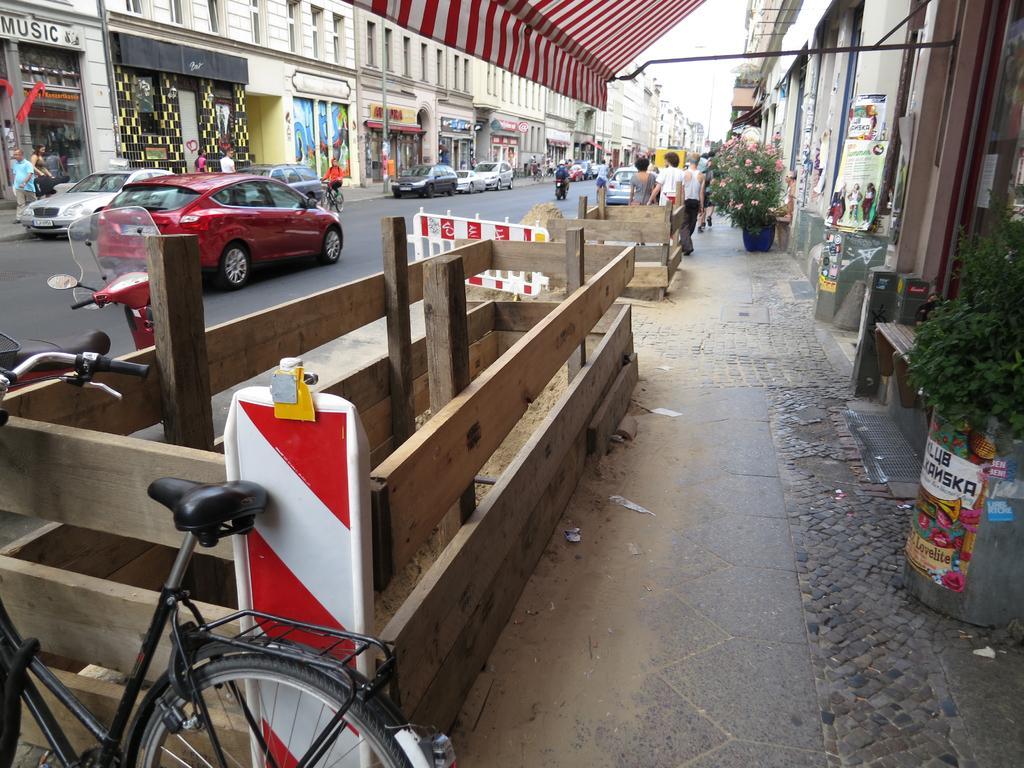How would you summarize this image in a sentence or two? In this image I can see group of people walking on the road, I can also see few vehicle on the road. In front the vehicle is in red color, background I can see few buildings in white and cream color, trees in green color and the sky is in white color. 